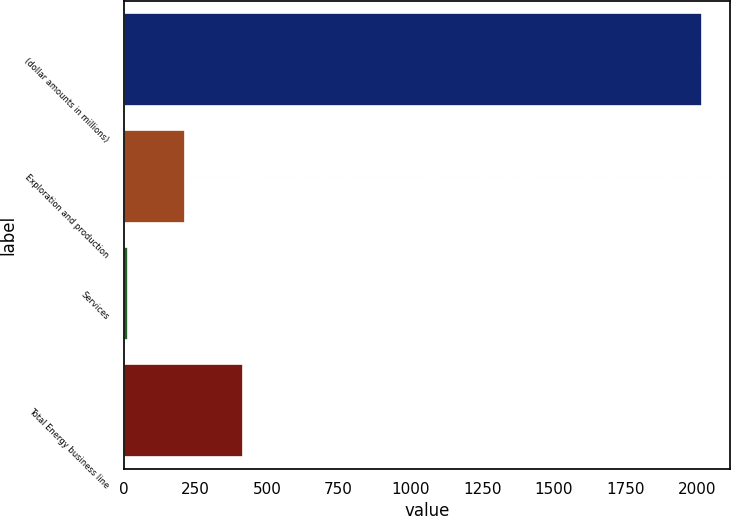Convert chart to OTSL. <chart><loc_0><loc_0><loc_500><loc_500><bar_chart><fcel>(dollar amounts in millions)<fcel>Exploration and production<fcel>Services<fcel>Total Energy business line<nl><fcel>2015<fcel>215.9<fcel>16<fcel>415.8<nl></chart> 